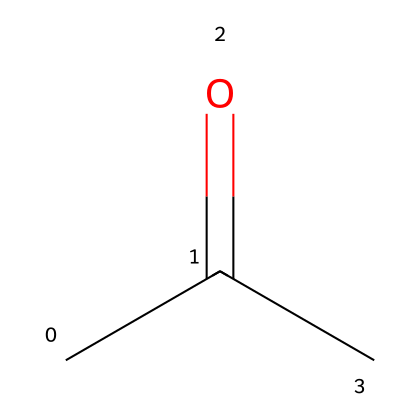How many carbon atoms are in this structure? By examining the SMILES representation "CC(=O)C," you can count the number of 'C' letters which represent carbon atoms. There are three 'C's in total.
Answer: 3 What is the functional group present in this compound? The SMILES notation shows "=O" next to a carbon which signifies a carbonyl group, characteristic of ketones. This indicates that the functional group is a ketone.
Answer: ketone What is the total number of hydrogen atoms in this molecule? The structure "CC(=O)C" includes three carbon atoms. The first two carbons (C) are considered in a saturated context, which typically can bond with three hydrogen atoms each, and the third carbon can bond with three as well minus one due to the carbonyl group (having one less due to a double bond with oxygen). This gives a total of 8 hydrogen atoms: (3 from the first C + 3 from the second C + 2 from the third C) = 8.
Answer: 8 What type of solvent is acetone commonly classified as? Acetone is a common solvent known for its ability to dissolve many organic compounds and is classified as a polar aprotic solvent, due to its molecular structure and characteristics.
Answer: polar aprotic What is the boiling point range for acetone? The boiling point of acetone is well-known and generally falls between 56 to 57 degrees Celsius, a specific property linked to its molecular structure.
Answer: 56-57 Can acetone be mixed with water? Acetone is miscible with water due to its polar characteristics and the ability to form hydrogen bonds, which allows for a complete mixing of the two compounds.
Answer: yes 